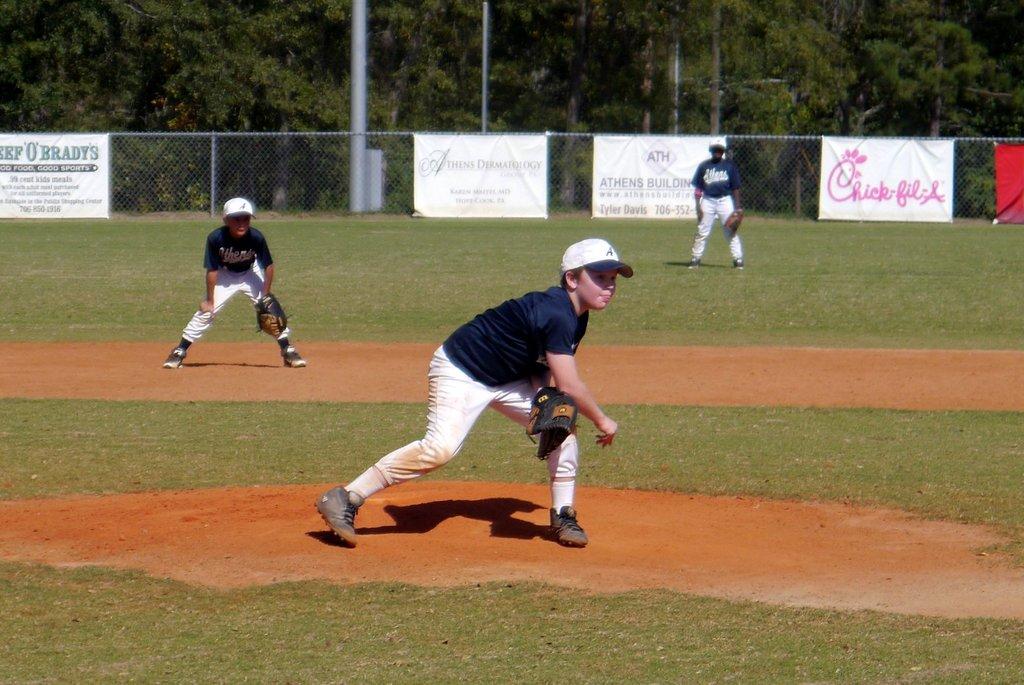What is the business being advertised on the far left of the fence?
Provide a succinct answer. Beef 'o' brady's. 